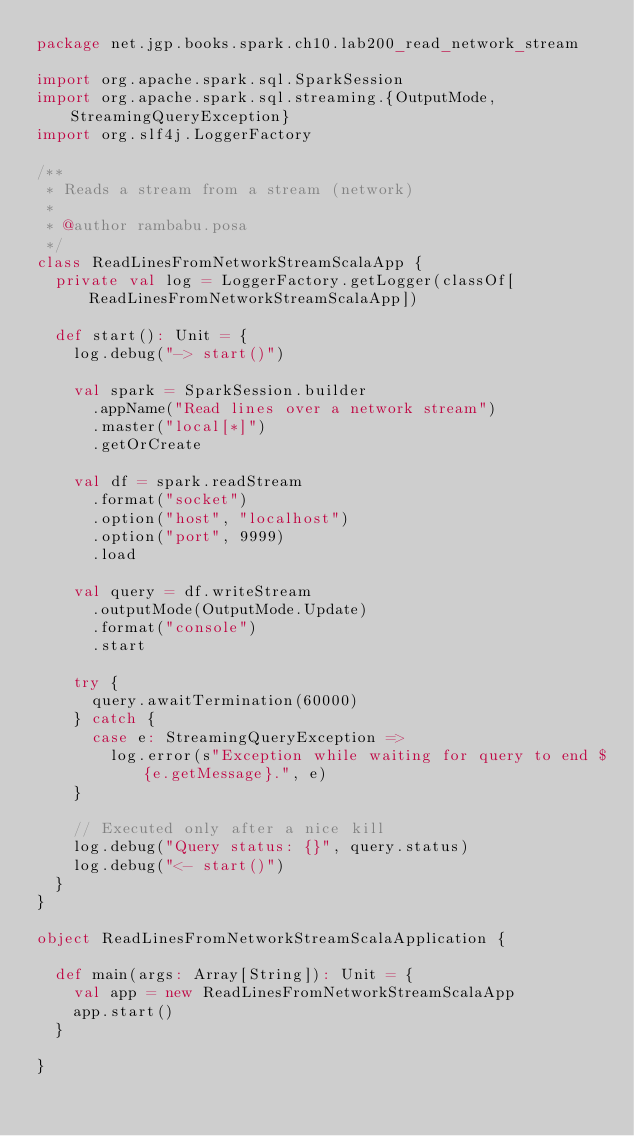Convert code to text. <code><loc_0><loc_0><loc_500><loc_500><_Scala_>package net.jgp.books.spark.ch10.lab200_read_network_stream

import org.apache.spark.sql.SparkSession
import org.apache.spark.sql.streaming.{OutputMode, StreamingQueryException}
import org.slf4j.LoggerFactory

/**
 * Reads a stream from a stream (network)
 *
 * @author rambabu.posa
 */
class ReadLinesFromNetworkStreamScalaApp {
  private val log = LoggerFactory.getLogger(classOf[ReadLinesFromNetworkStreamScalaApp])

  def start(): Unit = {
    log.debug("-> start()")

    val spark = SparkSession.builder
      .appName("Read lines over a network stream")
      .master("local[*]")
      .getOrCreate

    val df = spark.readStream
      .format("socket")
      .option("host", "localhost")
      .option("port", 9999)
      .load

    val query = df.writeStream
      .outputMode(OutputMode.Update)
      .format("console")
      .start

    try {
      query.awaitTermination(60000)
    } catch {
      case e: StreamingQueryException =>
        log.error(s"Exception while waiting for query to end ${e.getMessage}.", e)
    }

    // Executed only after a nice kill
    log.debug("Query status: {}", query.status)
    log.debug("<- start()")
  }
}

object ReadLinesFromNetworkStreamScalaApplication {

  def main(args: Array[String]): Unit = {
    val app = new ReadLinesFromNetworkStreamScalaApp
    app.start()
  }

}
</code> 